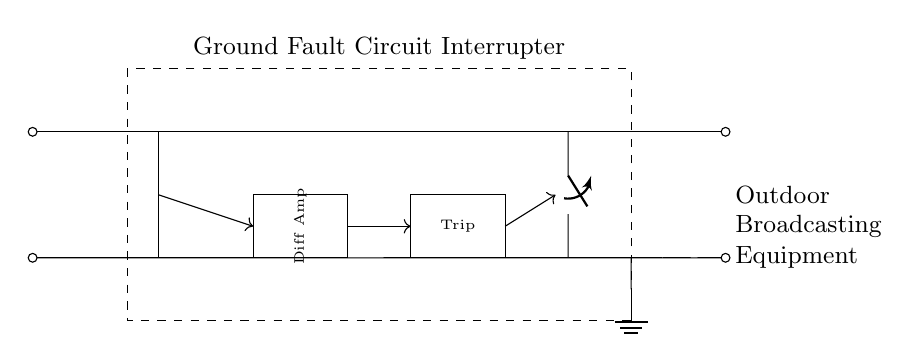What does the rectangle labeled "Ground Fault Circuit Interrupter" indicate? The rectangle represents a Ground Fault Circuit Interrupter, which is a safety device designed to protect against electrical shocks by cutting off the electrical supply when a ground fault is detected.
Answer: Ground Fault Circuit Interrupter How many main components are shown in the circuit? The main components consist of a Ground Fault Circuit Interrupter, a sense coil, a differential amplifier, a trip circuit, a circuit breaker, and the load for outdoor broadcasting equipment. Thus, there are six main components in total.
Answer: Six What is the function of the differential amplifier? The differential amplifier amplifies the difference in current between the hot and neutral wires to detect any ground faults, which is crucial for the GFCI operation to identify electrical imbalances.
Answer: Detects ground faults What triggers the circuit breaker in this diagram? The trip circuit receives a signal from the differential amplifier when a ground fault is detected, causing the circuit breaker to open and disconnect the electrical supply to prevent electric shock.
Answer: Trip circuit signal Where does the ground connection lead? The ground connection leads to the ground symbol at the bottom of the rectangle, indicating that it is connected to the earth to safely dissipate any fault current and prevent electric shock hazards.
Answer: Ground connection What type of load is indicated in the circuit? The load referred to in the circuit is meant for outdoor broadcasting equipment, which suggests it is specialized for use in broadcasting contexts where outdoor conditions are prevalent, requiring protection against ground faults.
Answer: Outdoor Broadcasting Equipment 